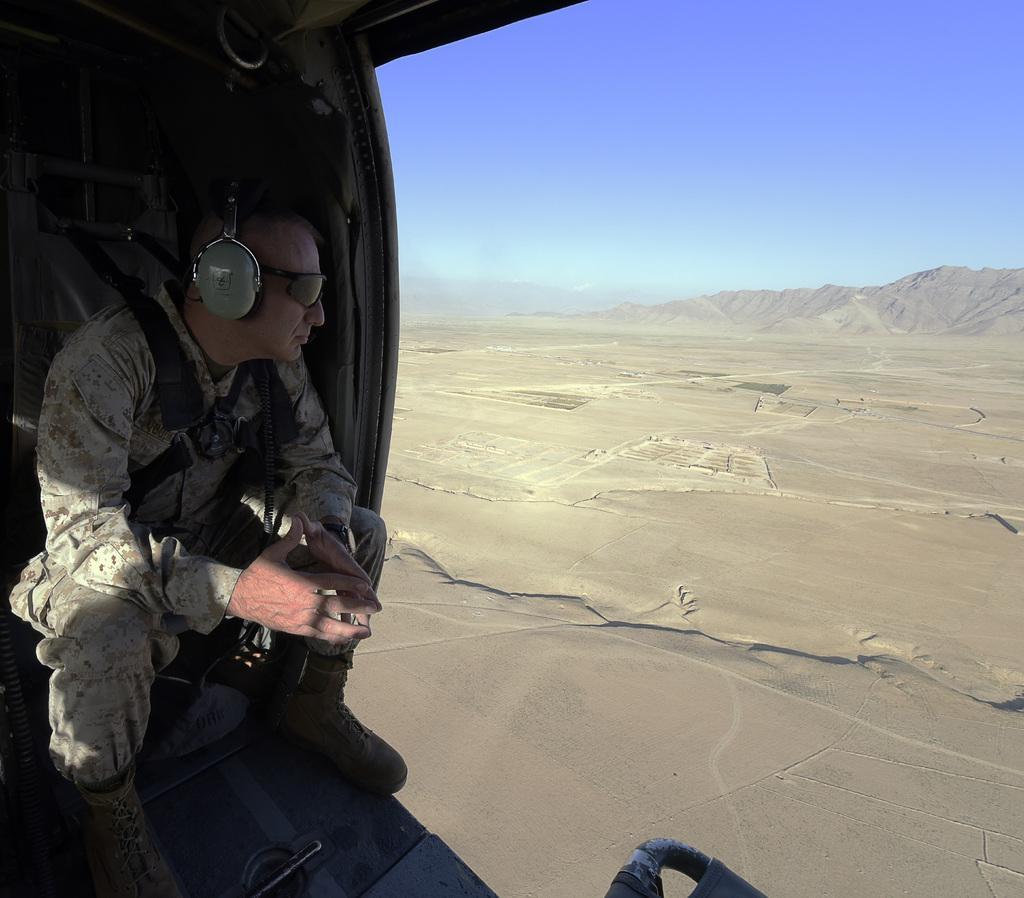In one or two sentences, can you explain what this image depicts? On the left side of the image there is a person, headset, goggles and objects. Person wore headset and goggles. On the right side of the image there is sand, hills and sky. 